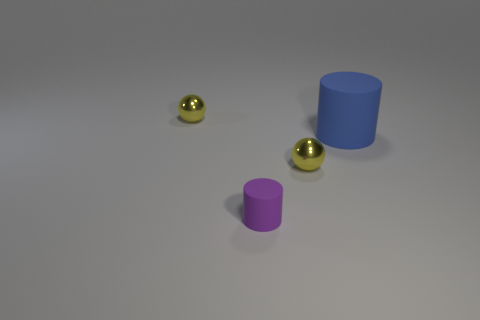Is the number of yellow spheres that are in front of the small purple thing greater than the number of large matte things that are to the left of the blue matte cylinder?
Make the answer very short. No. Are there more purple cylinders than tiny yellow metal balls?
Make the answer very short. No. There is a blue thing; what shape is it?
Your response must be concise. Cylinder. Is there anything else that has the same size as the blue rubber cylinder?
Provide a short and direct response. No. Are there more yellow objects in front of the blue cylinder than tiny brown things?
Provide a succinct answer. Yes. The small object behind the shiny thing that is in front of the sphere behind the large blue object is what shape?
Ensure brevity in your answer.  Sphere. There is a shiny sphere that is to the right of the purple matte cylinder; is it the same size as the tiny cylinder?
Offer a terse response. Yes. There is a thing that is left of the blue cylinder and on the right side of the purple cylinder; what shape is it?
Offer a very short reply. Sphere. Does the large object have the same color as the rubber object in front of the blue thing?
Provide a succinct answer. No. The tiny metallic sphere behind the big matte cylinder right of the sphere that is in front of the large blue matte cylinder is what color?
Give a very brief answer. Yellow. 